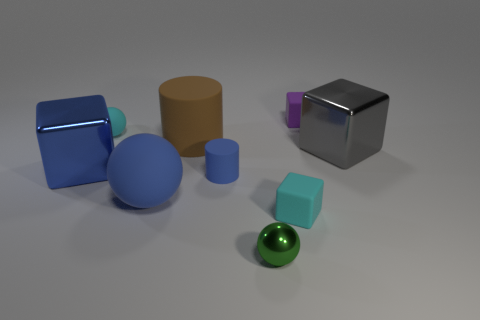What size is the rubber ball that is the same color as the small cylinder?
Offer a terse response. Large. What material is the large cube that is the same color as the big sphere?
Your answer should be compact. Metal. Are there more green metal spheres in front of the cyan ball than rubber objects?
Ensure brevity in your answer.  No. Are there any other things of the same color as the tiny matte cylinder?
Your answer should be compact. Yes. What shape is the purple thing that is made of the same material as the blue cylinder?
Offer a very short reply. Cube. Is the material of the cylinder in front of the large gray thing the same as the large ball?
Your answer should be compact. Yes. There is a large matte object that is the same color as the tiny cylinder; what shape is it?
Keep it short and to the point. Sphere. There is a small cube in front of the tiny purple rubber cube; is its color the same as the small sphere that is on the right side of the blue cylinder?
Your response must be concise. No. What number of things are behind the big sphere and right of the tiny rubber ball?
Provide a short and direct response. 4. What is the big sphere made of?
Keep it short and to the point. Rubber. 